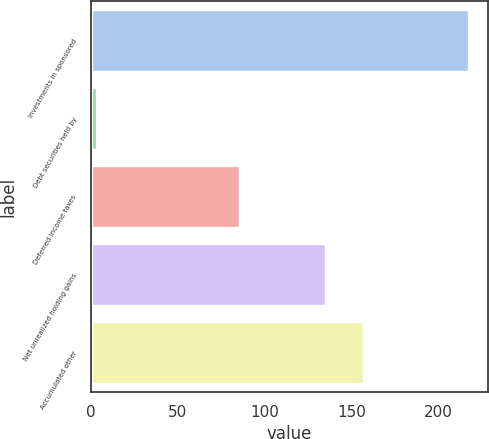<chart> <loc_0><loc_0><loc_500><loc_500><bar_chart><fcel>Investments in sponsored<fcel>Debt securities held by<fcel>Deferred income taxes<fcel>Net unrealized holding gains<fcel>Accumulated other<nl><fcel>217.7<fcel>3.3<fcel>85.5<fcel>135.5<fcel>156.94<nl></chart> 